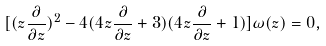<formula> <loc_0><loc_0><loc_500><loc_500>[ ( z \frac { \partial } { \partial z } ) ^ { 2 } - 4 ( 4 z \frac { \partial } { \partial z } + 3 ) ( 4 z \frac { \partial } { \partial z } + 1 ) ] \omega ( z ) = 0 ,</formula> 